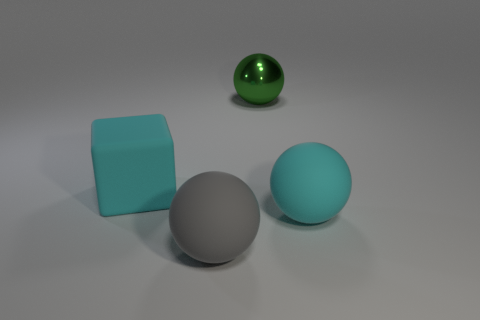Add 2 cyan objects. How many objects exist? 6 Subtract all blocks. How many objects are left? 3 Subtract all green balls. Subtract all large gray things. How many objects are left? 2 Add 1 rubber spheres. How many rubber spheres are left? 3 Add 4 big blue things. How many big blue things exist? 4 Subtract 0 purple blocks. How many objects are left? 4 